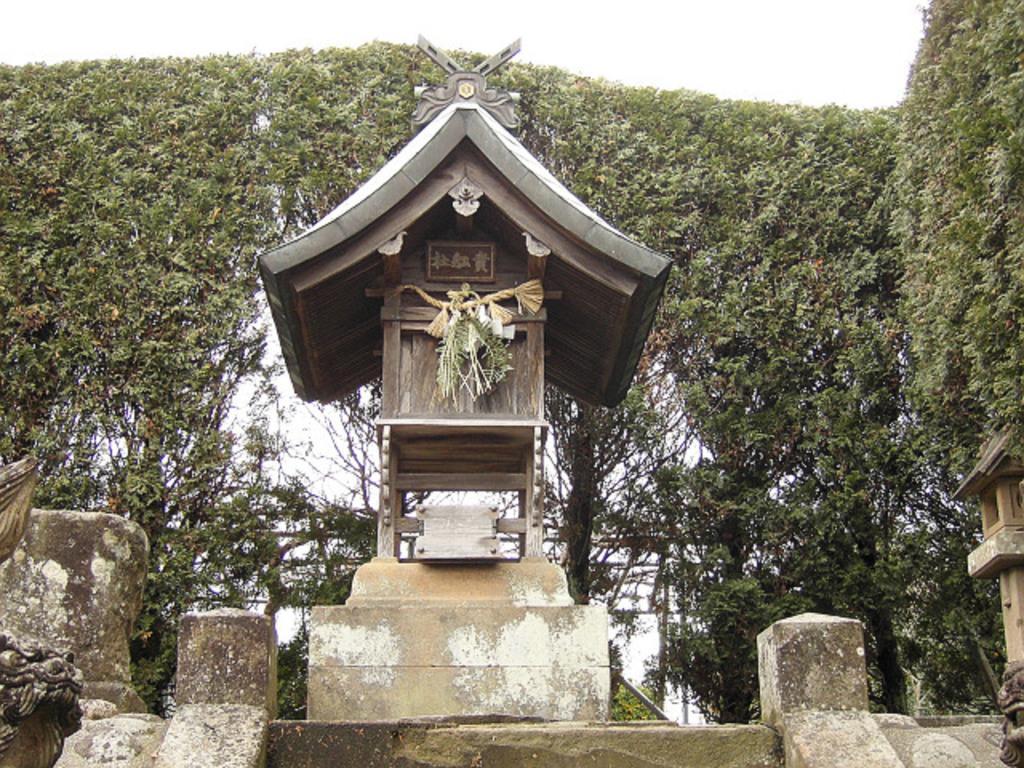Please provide a concise description of this image. In this picture in the middle, we can see a wood box. On the right side, we can see some trees. In the background, we can also see some trees. On the top there there is a sky, at the bottom, we can see some stones. 